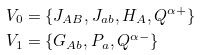<formula> <loc_0><loc_0><loc_500><loc_500>V _ { 0 } & = \{ J _ { A B } , J _ { a b } , H _ { A } , Q ^ { \alpha + } \} \\ V _ { 1 } & = \{ G _ { A b } , P _ { a } , Q ^ { \alpha - } \}</formula> 